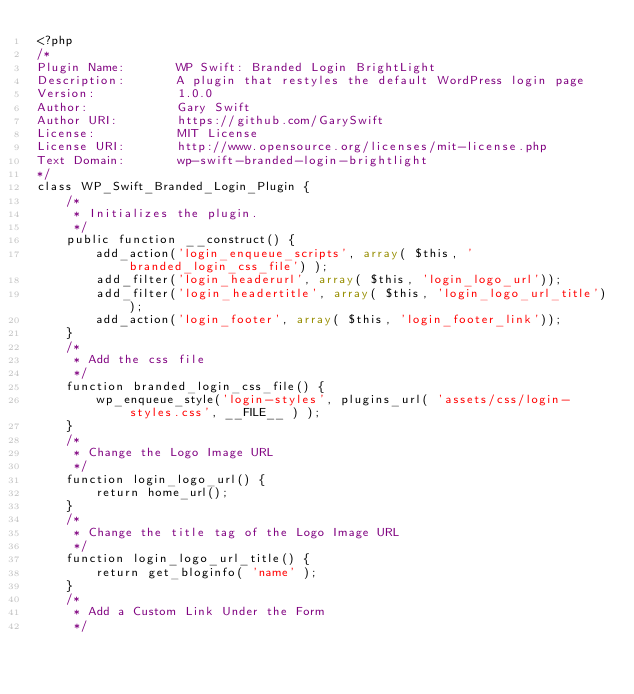<code> <loc_0><loc_0><loc_500><loc_500><_PHP_><?php
/*
Plugin Name:       WP Swift: Branded Login BrightLight
Description:       A plugin that restyles the default WordPress login page
Version:           1.0.0
Author:            Gary Swift
Author URI:        https://github.com/GarySwift
License:           MIT License
License URI:       http://www.opensource.org/licenses/mit-license.php
Text Domain:       wp-swift-branded-login-brightlight
*/
class WP_Swift_Branded_Login_Plugin {
    /*
     * Initializes the plugin.
     */
    public function __construct() {
        add_action('login_enqueue_scripts', array( $this, 'branded_login_css_file') );
        add_filter('login_headerurl', array( $this, 'login_logo_url'));
        add_filter('login_headertitle', array( $this, 'login_logo_url_title'));
        add_action('login_footer', array( $this, 'login_footer_link'));
    }
    /*
     * Add the css file
     */
    function branded_login_css_file() {
        wp_enqueue_style('login-styles', plugins_url( 'assets/css/login-styles.css', __FILE__ ) );
    }
    /*
     * Change the Logo Image URL
     */
    function login_logo_url() {
        return home_url();
    }
    /*
     * Change the title tag of the Logo Image URL
     */
    function login_logo_url_title() {
        return get_bloginfo( 'name' );
    }
    /*
     * Add a Custom Link Under the Form
     */</code> 